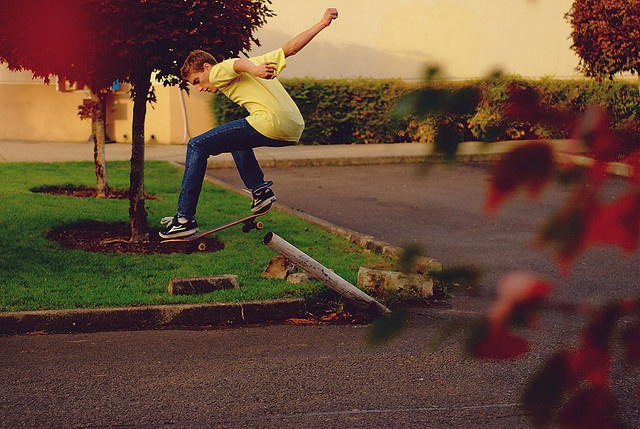Describe the objects in this image and their specific colors. I can see people in maroon, black, tan, khaki, and olive tones and skateboard in maroon, black, and darkgreen tones in this image. 